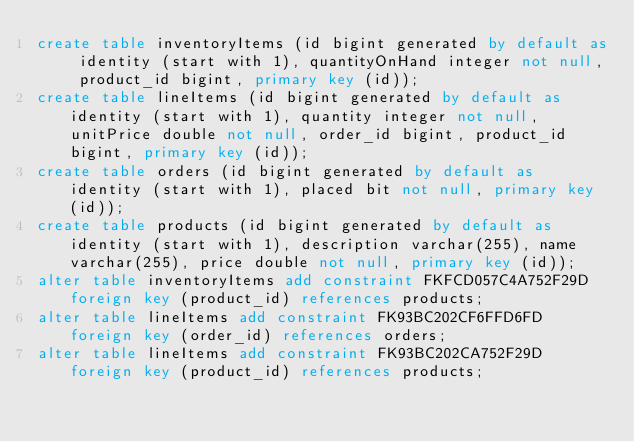<code> <loc_0><loc_0><loc_500><loc_500><_SQL_>create table inventoryItems (id bigint generated by default as identity (start with 1), quantityOnHand integer not null, product_id bigint, primary key (id));
create table lineItems (id bigint generated by default as identity (start with 1), quantity integer not null, unitPrice double not null, order_id bigint, product_id bigint, primary key (id));
create table orders (id bigint generated by default as identity (start with 1), placed bit not null, primary key (id));
create table products (id bigint generated by default as identity (start with 1), description varchar(255), name varchar(255), price double not null, primary key (id));
alter table inventoryItems add constraint FKFCD057C4A752F29D foreign key (product_id) references products;
alter table lineItems add constraint FK93BC202CF6FFD6FD foreign key (order_id) references orders;
alter table lineItems add constraint FK93BC202CA752F29D foreign key (product_id) references products;
</code> 